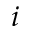Convert formula to latex. <formula><loc_0><loc_0><loc_500><loc_500>i</formula> 